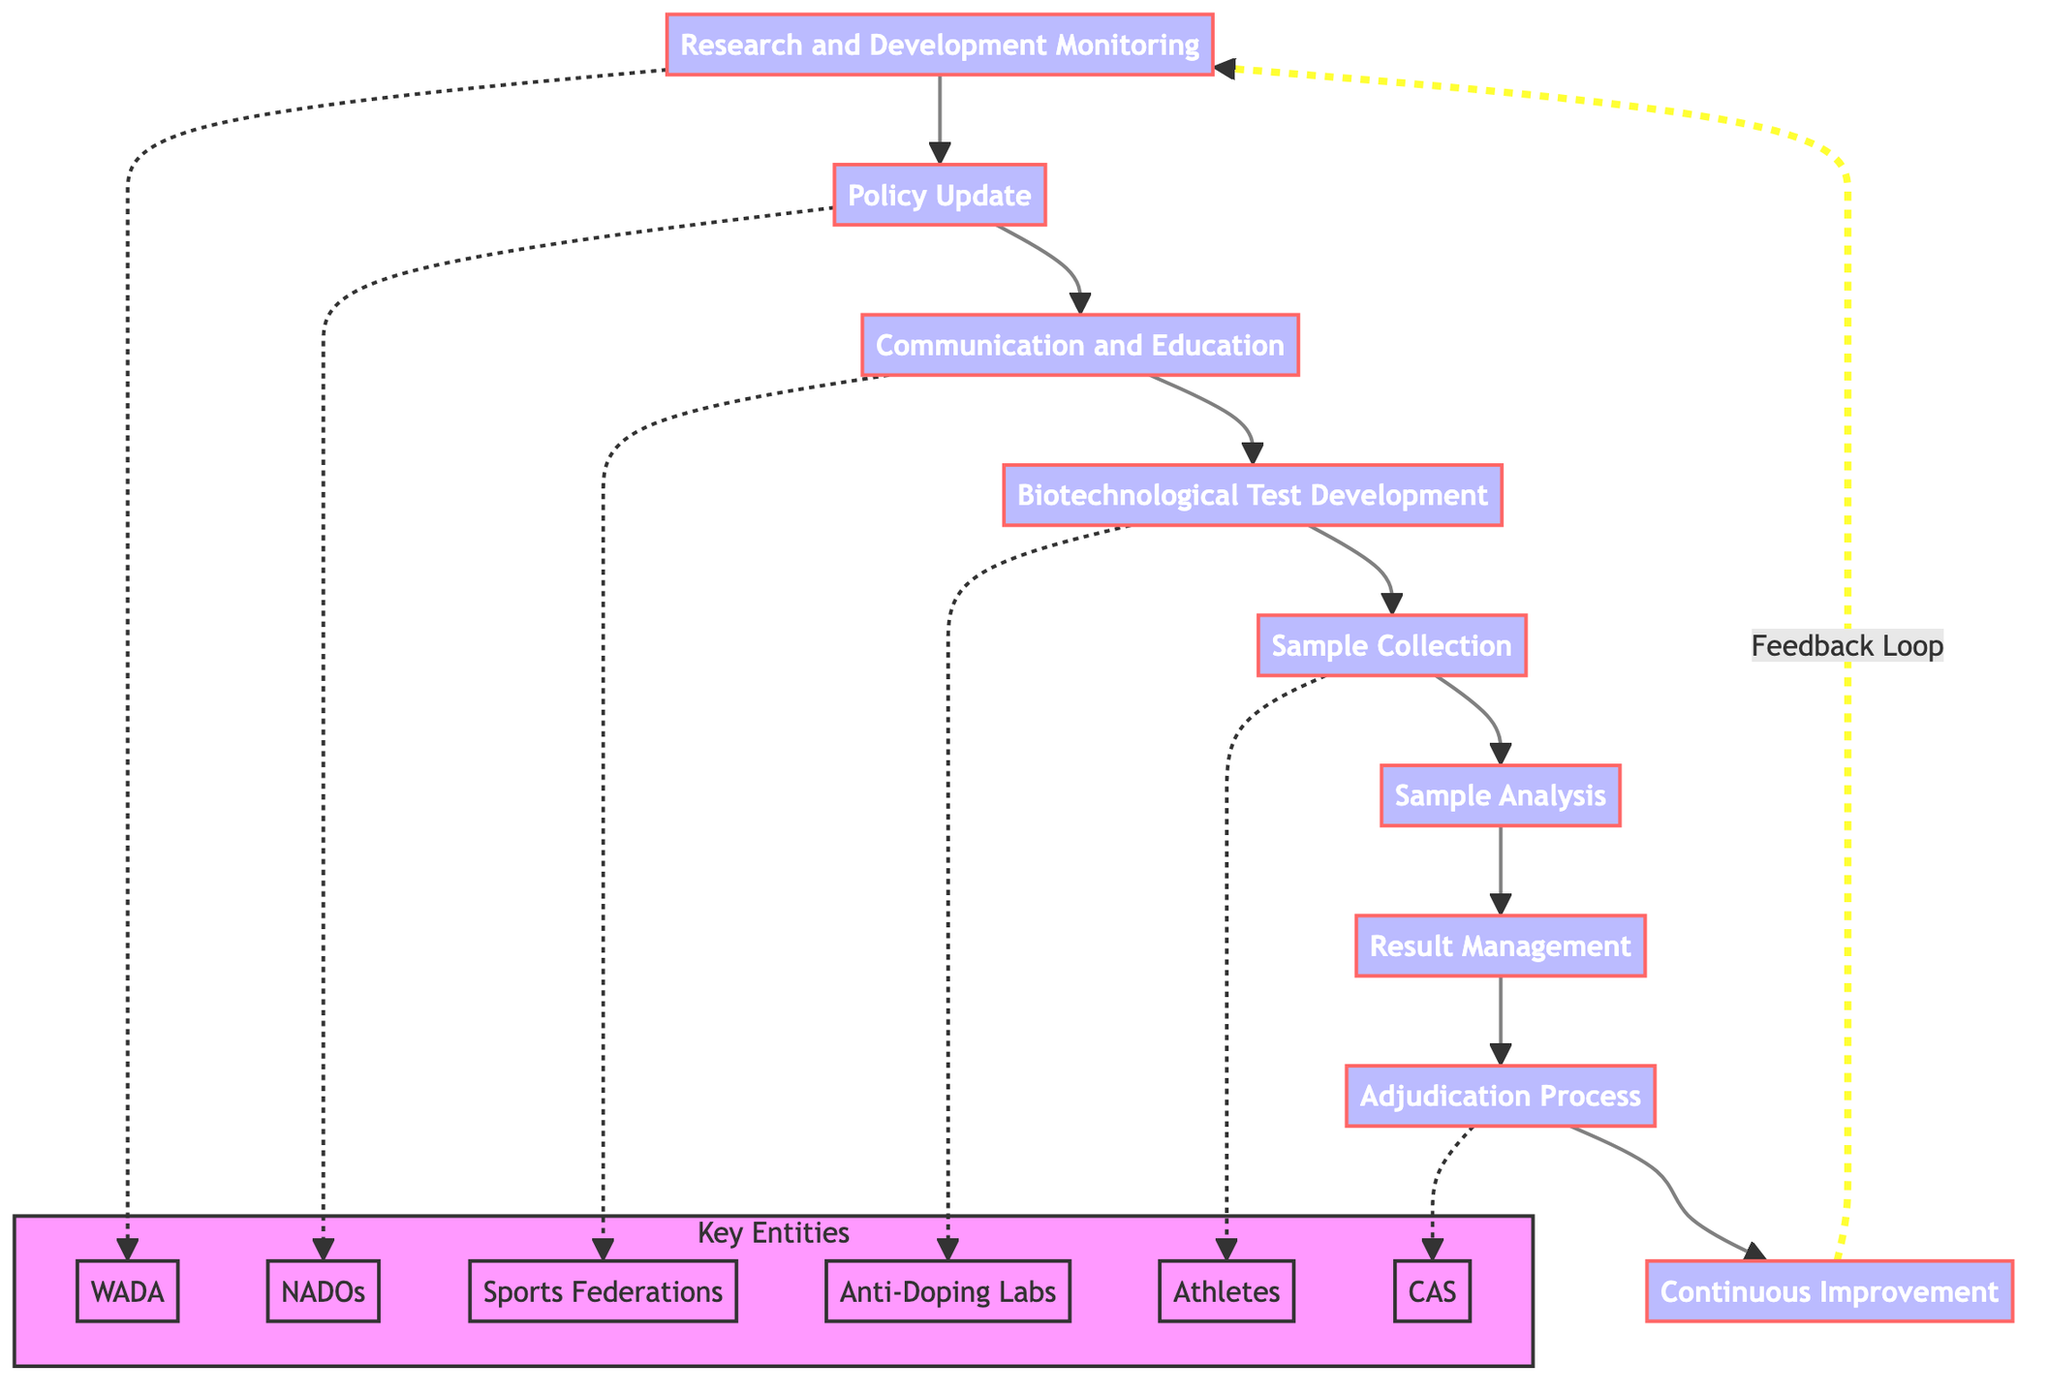What's the first step in the workflow? The first step in the workflow, as indicated in the diagram, is "Research and Development Monitoring." This step initiates the entire workflow process.
Answer: Research and Development Monitoring How many total steps are there in the workflow? By counting the steps outlined in the diagram, there are a total of nine steps that make up the workflow.
Answer: Nine Which step comes after "Sample Analysis"? The step that directly follows "Sample Analysis" in the workflow is "Result Management." This sequence indicates the flow of the process.
Answer: Result Management What entities are involved in the "Policy Update" step? The entities involved in the "Policy Update" step, as shown in the diagram, are "National Anti-Doping Organizations (NADOs)" and "WADA." These entities play a vital role in updating the anti-doping policies.
Answer: National Anti-Doping Organizations (NADOs), WADA Which step leads back to "Research and Development Monitoring" after completing the workflow? The step that leads back to "Research and Development Monitoring" after completing the workflow is "Continuous Improvement." This reflects the iterative nature of the process based on feedback.
Answer: Continuous Improvement In what way does "Continuous Improvement" relate to the other steps? "Continuous Improvement" serves as a feedback loop that allows for adjustments and enhancements to the workflow based on new advancements and feedback collected from previous steps.
Answer: Feedback Loop What is the purpose of the "Sample Collection" step? The purpose of the "Sample Collection" step, as indicated, is to gather biological samples from athletes for the purpose of testing, which is a crucial part of the overall anti-doping process.
Answer: Collect biological samples from athletes Who conducts the "Adjudication Process"? The "Adjudication Process" is conducted by entities such as the "Court of Arbitration for Sport (CAS)," "National Anti-Doping Organizations (NADOs)," and "Athlete Legal Representatives," who manage hearings related to rule violations.
Answer: Court of Arbitration for Sport (CAS), National Anti-Doping Organizations (NADOs), Athlete Legal Representatives Which step focuses on educating athletes about risks? The step focusing on educating athletes and stakeholders about risks is "Communication and Education," which is crucial for raising awareness on new policies and potential hazards associated with biotechnological advancements.
Answer: Communication and Education 